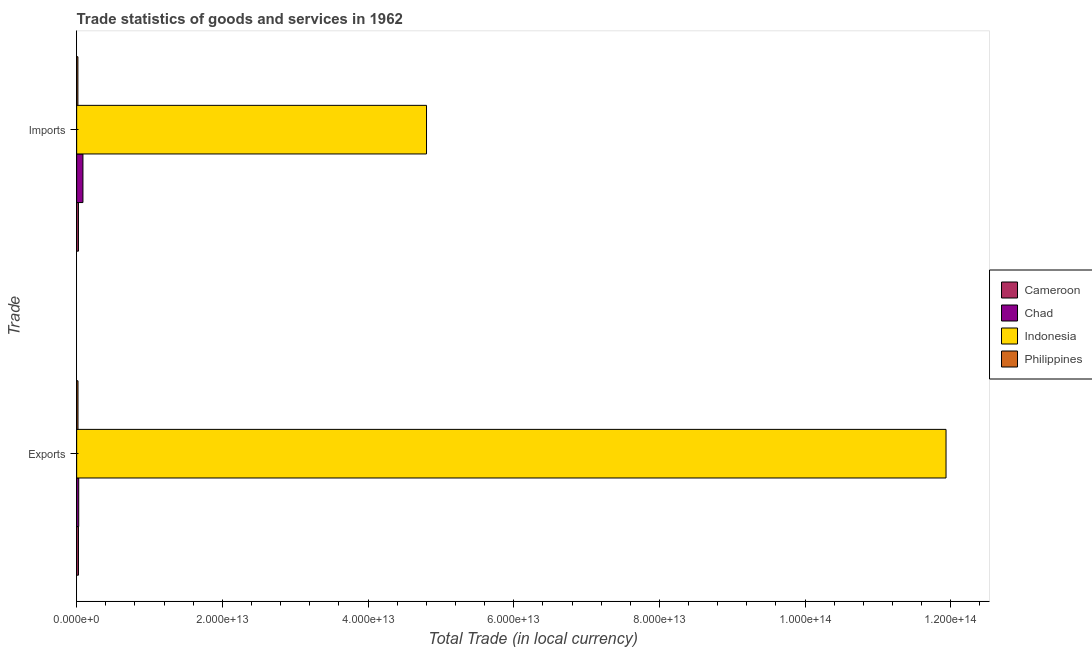Are the number of bars on each tick of the Y-axis equal?
Provide a short and direct response. Yes. What is the label of the 2nd group of bars from the top?
Make the answer very short. Exports. What is the imports of goods and services in Chad?
Your answer should be very brief. 8.62e+11. Across all countries, what is the maximum export of goods and services?
Keep it short and to the point. 1.19e+14. Across all countries, what is the minimum export of goods and services?
Keep it short and to the point. 1.85e+11. What is the total imports of goods and services in the graph?
Keep it short and to the point. 4.93e+13. What is the difference between the imports of goods and services in Cameroon and that in Chad?
Give a very brief answer. -6.16e+11. What is the difference between the imports of goods and services in Indonesia and the export of goods and services in Chad?
Your answer should be very brief. 4.77e+13. What is the average export of goods and services per country?
Provide a short and direct response. 3.00e+13. What is the difference between the export of goods and services and imports of goods and services in Cameroon?
Ensure brevity in your answer.  1.57e+09. What is the ratio of the export of goods and services in Indonesia to that in Cameroon?
Ensure brevity in your answer.  481.83. How many bars are there?
Provide a short and direct response. 8. Are all the bars in the graph horizontal?
Give a very brief answer. Yes. How many countries are there in the graph?
Ensure brevity in your answer.  4. What is the difference between two consecutive major ticks on the X-axis?
Keep it short and to the point. 2.00e+13. Are the values on the major ticks of X-axis written in scientific E-notation?
Provide a succinct answer. Yes. Does the graph contain any zero values?
Offer a terse response. No. Does the graph contain grids?
Make the answer very short. No. Where does the legend appear in the graph?
Offer a terse response. Center right. What is the title of the graph?
Give a very brief answer. Trade statistics of goods and services in 1962. What is the label or title of the X-axis?
Give a very brief answer. Total Trade (in local currency). What is the label or title of the Y-axis?
Ensure brevity in your answer.  Trade. What is the Total Trade (in local currency) of Cameroon in Exports?
Make the answer very short. 2.48e+11. What is the Total Trade (in local currency) in Chad in Exports?
Give a very brief answer. 2.82e+11. What is the Total Trade (in local currency) of Indonesia in Exports?
Your response must be concise. 1.19e+14. What is the Total Trade (in local currency) of Philippines in Exports?
Provide a succinct answer. 1.85e+11. What is the Total Trade (in local currency) of Cameroon in Imports?
Make the answer very short. 2.46e+11. What is the Total Trade (in local currency) of Chad in Imports?
Offer a terse response. 8.62e+11. What is the Total Trade (in local currency) in Indonesia in Imports?
Your response must be concise. 4.80e+13. What is the Total Trade (in local currency) of Philippines in Imports?
Your response must be concise. 1.71e+11. Across all Trade, what is the maximum Total Trade (in local currency) in Cameroon?
Offer a terse response. 2.48e+11. Across all Trade, what is the maximum Total Trade (in local currency) in Chad?
Keep it short and to the point. 8.62e+11. Across all Trade, what is the maximum Total Trade (in local currency) of Indonesia?
Offer a terse response. 1.19e+14. Across all Trade, what is the maximum Total Trade (in local currency) of Philippines?
Provide a succinct answer. 1.85e+11. Across all Trade, what is the minimum Total Trade (in local currency) in Cameroon?
Ensure brevity in your answer.  2.46e+11. Across all Trade, what is the minimum Total Trade (in local currency) in Chad?
Make the answer very short. 2.82e+11. Across all Trade, what is the minimum Total Trade (in local currency) of Indonesia?
Keep it short and to the point. 4.80e+13. Across all Trade, what is the minimum Total Trade (in local currency) of Philippines?
Your answer should be compact. 1.71e+11. What is the total Total Trade (in local currency) of Cameroon in the graph?
Give a very brief answer. 4.94e+11. What is the total Total Trade (in local currency) of Chad in the graph?
Keep it short and to the point. 1.14e+12. What is the total Total Trade (in local currency) in Indonesia in the graph?
Give a very brief answer. 1.67e+14. What is the total Total Trade (in local currency) in Philippines in the graph?
Provide a succinct answer. 3.55e+11. What is the difference between the Total Trade (in local currency) in Cameroon in Exports and that in Imports?
Your response must be concise. 1.57e+09. What is the difference between the Total Trade (in local currency) in Chad in Exports and that in Imports?
Provide a short and direct response. -5.80e+11. What is the difference between the Total Trade (in local currency) in Indonesia in Exports and that in Imports?
Offer a terse response. 7.13e+13. What is the difference between the Total Trade (in local currency) in Philippines in Exports and that in Imports?
Keep it short and to the point. 1.36e+1. What is the difference between the Total Trade (in local currency) in Cameroon in Exports and the Total Trade (in local currency) in Chad in Imports?
Provide a succinct answer. -6.14e+11. What is the difference between the Total Trade (in local currency) of Cameroon in Exports and the Total Trade (in local currency) of Indonesia in Imports?
Your answer should be very brief. -4.78e+13. What is the difference between the Total Trade (in local currency) in Cameroon in Exports and the Total Trade (in local currency) in Philippines in Imports?
Make the answer very short. 7.67e+1. What is the difference between the Total Trade (in local currency) in Chad in Exports and the Total Trade (in local currency) in Indonesia in Imports?
Ensure brevity in your answer.  -4.77e+13. What is the difference between the Total Trade (in local currency) in Chad in Exports and the Total Trade (in local currency) in Philippines in Imports?
Your response must be concise. 1.11e+11. What is the difference between the Total Trade (in local currency) of Indonesia in Exports and the Total Trade (in local currency) of Philippines in Imports?
Your answer should be compact. 1.19e+14. What is the average Total Trade (in local currency) in Cameroon per Trade?
Your response must be concise. 2.47e+11. What is the average Total Trade (in local currency) in Chad per Trade?
Give a very brief answer. 5.72e+11. What is the average Total Trade (in local currency) in Indonesia per Trade?
Ensure brevity in your answer.  8.37e+13. What is the average Total Trade (in local currency) in Philippines per Trade?
Give a very brief answer. 1.78e+11. What is the difference between the Total Trade (in local currency) of Cameroon and Total Trade (in local currency) of Chad in Exports?
Provide a succinct answer. -3.46e+1. What is the difference between the Total Trade (in local currency) in Cameroon and Total Trade (in local currency) in Indonesia in Exports?
Provide a succinct answer. -1.19e+14. What is the difference between the Total Trade (in local currency) of Cameroon and Total Trade (in local currency) of Philippines in Exports?
Make the answer very short. 6.32e+1. What is the difference between the Total Trade (in local currency) in Chad and Total Trade (in local currency) in Indonesia in Exports?
Keep it short and to the point. -1.19e+14. What is the difference between the Total Trade (in local currency) in Chad and Total Trade (in local currency) in Philippines in Exports?
Your answer should be compact. 9.78e+1. What is the difference between the Total Trade (in local currency) in Indonesia and Total Trade (in local currency) in Philippines in Exports?
Give a very brief answer. 1.19e+14. What is the difference between the Total Trade (in local currency) in Cameroon and Total Trade (in local currency) in Chad in Imports?
Give a very brief answer. -6.16e+11. What is the difference between the Total Trade (in local currency) in Cameroon and Total Trade (in local currency) in Indonesia in Imports?
Give a very brief answer. -4.78e+13. What is the difference between the Total Trade (in local currency) of Cameroon and Total Trade (in local currency) of Philippines in Imports?
Offer a very short reply. 7.52e+1. What is the difference between the Total Trade (in local currency) in Chad and Total Trade (in local currency) in Indonesia in Imports?
Provide a succinct answer. -4.72e+13. What is the difference between the Total Trade (in local currency) of Chad and Total Trade (in local currency) of Philippines in Imports?
Provide a succinct answer. 6.91e+11. What is the difference between the Total Trade (in local currency) of Indonesia and Total Trade (in local currency) of Philippines in Imports?
Give a very brief answer. 4.79e+13. What is the ratio of the Total Trade (in local currency) in Cameroon in Exports to that in Imports?
Ensure brevity in your answer.  1.01. What is the ratio of the Total Trade (in local currency) of Chad in Exports to that in Imports?
Your answer should be very brief. 0.33. What is the ratio of the Total Trade (in local currency) of Indonesia in Exports to that in Imports?
Your answer should be compact. 2.48. What is the ratio of the Total Trade (in local currency) of Philippines in Exports to that in Imports?
Give a very brief answer. 1.08. What is the difference between the highest and the second highest Total Trade (in local currency) of Cameroon?
Your answer should be very brief. 1.57e+09. What is the difference between the highest and the second highest Total Trade (in local currency) of Chad?
Provide a succinct answer. 5.80e+11. What is the difference between the highest and the second highest Total Trade (in local currency) in Indonesia?
Offer a very short reply. 7.13e+13. What is the difference between the highest and the second highest Total Trade (in local currency) in Philippines?
Give a very brief answer. 1.36e+1. What is the difference between the highest and the lowest Total Trade (in local currency) in Cameroon?
Provide a succinct answer. 1.57e+09. What is the difference between the highest and the lowest Total Trade (in local currency) in Chad?
Offer a terse response. 5.80e+11. What is the difference between the highest and the lowest Total Trade (in local currency) of Indonesia?
Provide a short and direct response. 7.13e+13. What is the difference between the highest and the lowest Total Trade (in local currency) in Philippines?
Ensure brevity in your answer.  1.36e+1. 